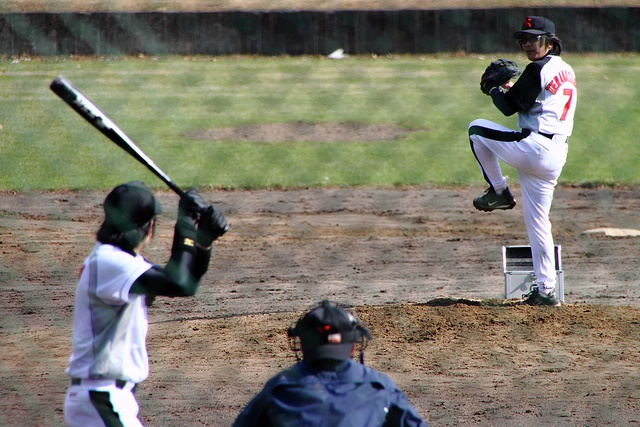Describe the objects in this image and their specific colors. I can see people in gray, black, and lavender tones, people in gray, black, lavender, and darkgray tones, people in gray, black, and navy tones, baseball bat in gray, black, white, and darkgray tones, and baseball glove in gray, black, darkgray, and navy tones in this image. 